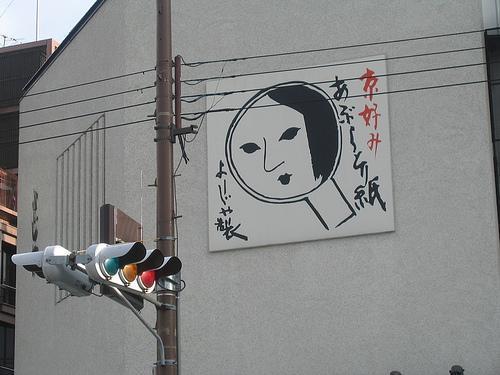How many girls are wearing a green shirt?
Give a very brief answer. 0. 